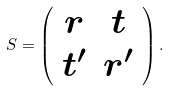Convert formula to latex. <formula><loc_0><loc_0><loc_500><loc_500>S = \left ( \begin{array} { c c } r & t \\ t ^ { \prime } & r ^ { \prime } \end{array} \right ) .</formula> 